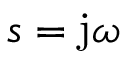Convert formula to latex. <formula><loc_0><loc_0><loc_500><loc_500>s = j \omega</formula> 